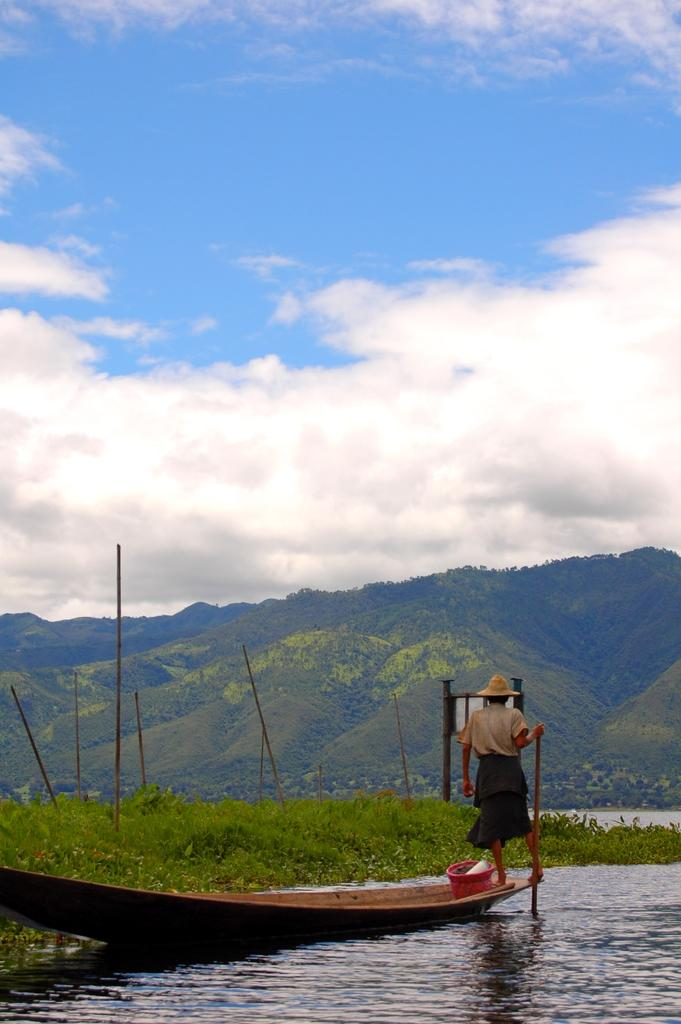What is the main subject of the image? The main subject of the image is a boat. Where is the boat located? The boat is on water. Can you describe the person in the image? There is a person in the image, but no specific details about them are provided. What else can be seen in the image besides the boat and person? There are sticks, plants, and objects visible in the image. What is visible in the background of the image? There are mountains and sky visible in the background of the image. Can you describe the sky in the image? The sky has clouds in it. What type of owl can be seen perched on the boat in the image? There is no owl present in the image; it features a boat on water with a person and other objects. What is the aftermath of the storm in the image? There is no mention of a storm or its aftermath in the image; it simply shows a boat on water with a person and other objects. 